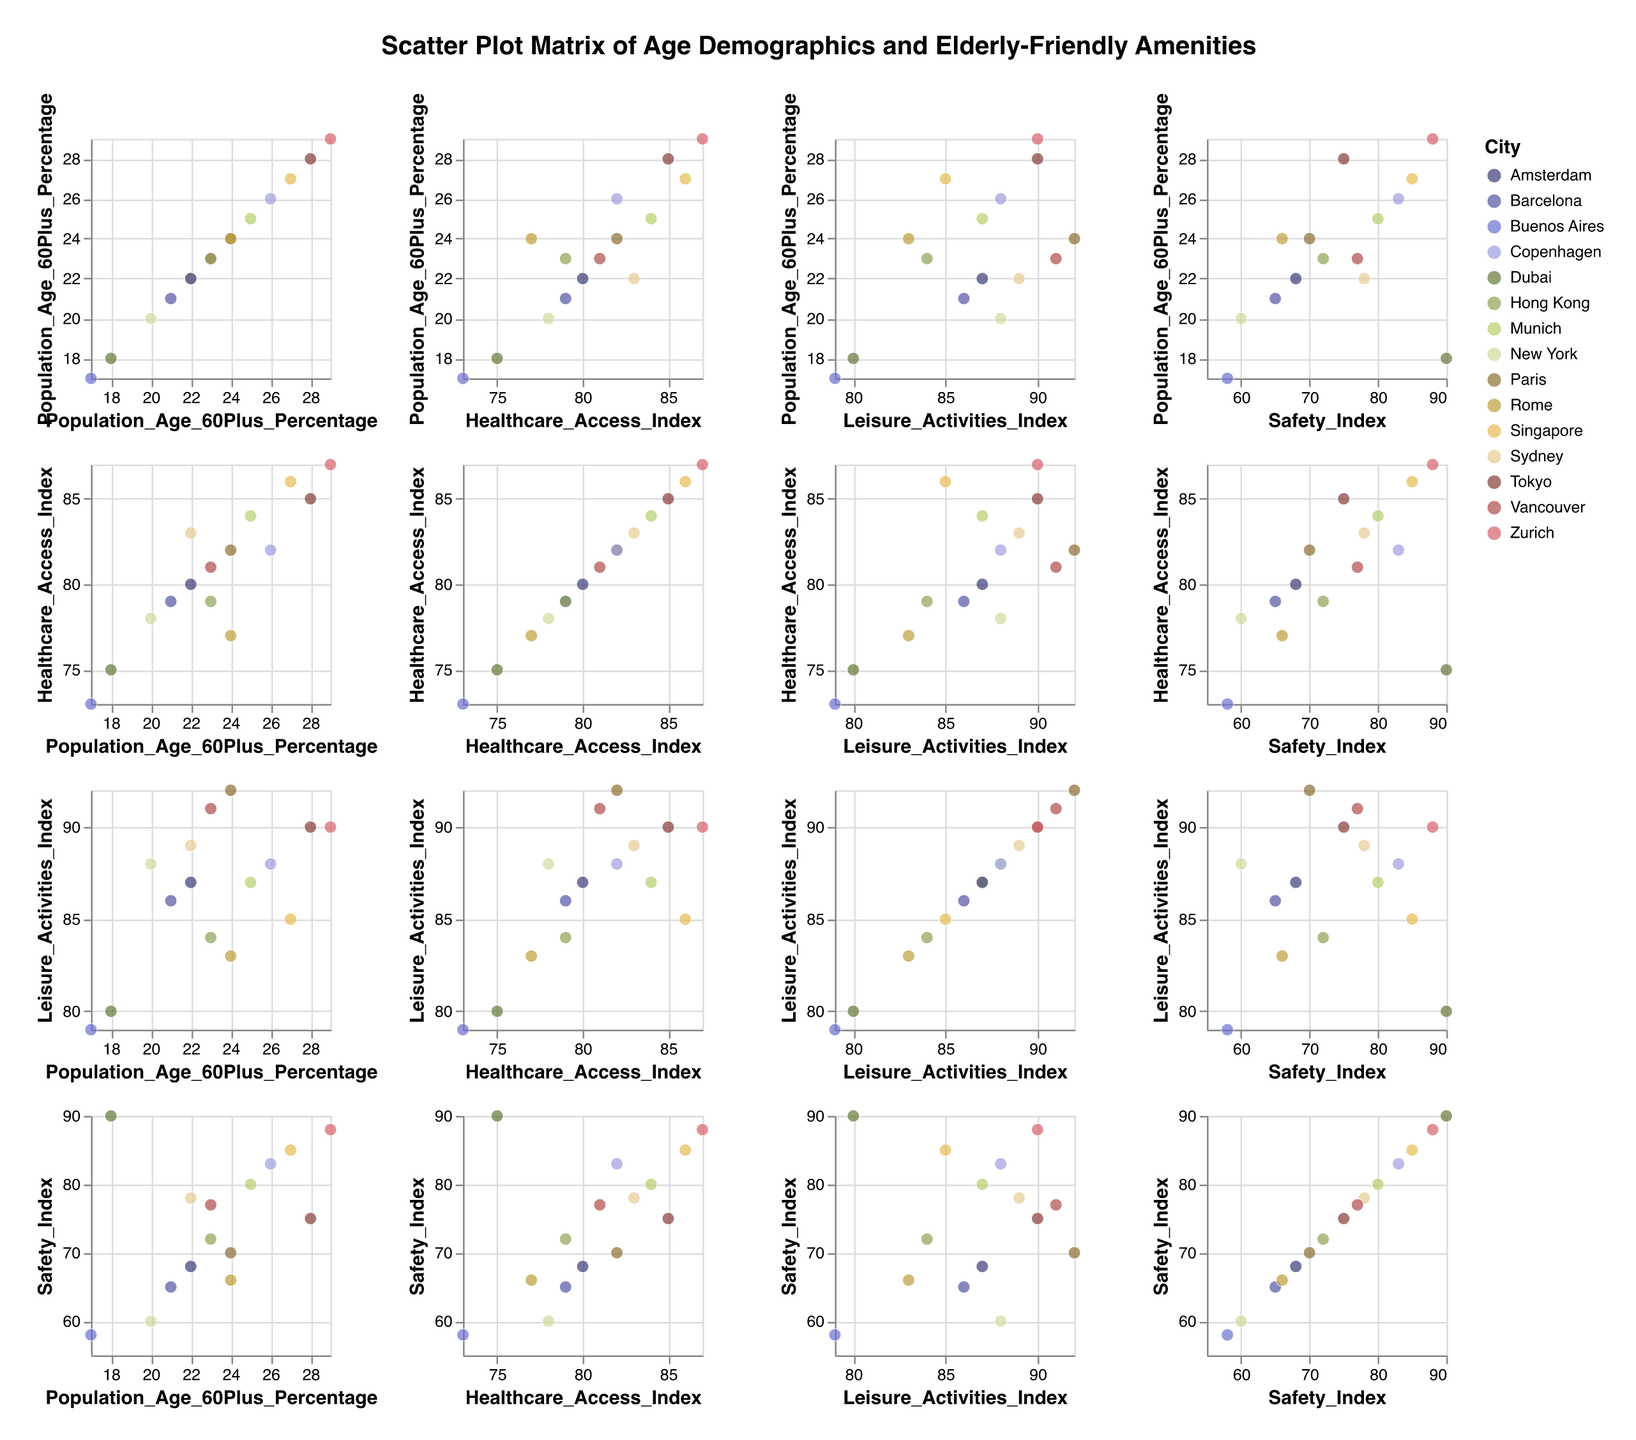What is the title of the figure? The title is displayed at the top of the figure and reads "Scatter Plot Matrix of Age Demographics and Elderly-Friendly Amenities."
Answer: Scatter Plot Matrix of Age Demographics and Elderly-Friendly Amenities Which city has the highest percentage of population aged 60 and above? By looking at the intersection column and row of "Population_Age_60Plus_Percentage," Zurich has the highest value at 29%.
Answer: Zurich Which cities have a Healthcare Access Index greater than or equal to 85? By examining the intersections of "Healthcare_Access_Index," cities with indices 85 or above are found. These cities are Tokyo, Singapore, and Zurich.
Answer: Tokyo, Singapore, Zurich Which city has the lowest Safety Index? By observing the row or column of "Safety_Index," Buenos Aires has the lowest value at 58.
Answer: Buenos Aires What is the average percentage of population aged 60 and above across all cities? Sum the percentages and divide by the number of cities: (28 + 24 + 20 + 25 + 22 + 23 + 21 + 27 + 26 + 22 + 29 + 23 + 24 + 18 + 17) / 15 = 339 / 15 = 22.6%.
Answer: 22.6% Do cities with a higher Safety Index also have better Healthcare Access? Compare pairs of "Safety_Index" and "Healthcare_Access_Index" values. Generally, cities with higher safety indices (like Zurich, Singapore) also have better healthcare access, but this is not a strict rule.
Answer: Generally yes, but not always What patterns do you notice between Leisure Activities Index and Healthcare Access Index across different cities? By analyzing the scatter plots at the intersections of "Leisure_Activities_Index" and "Healthcare_Access_Index," there is a slight positive correlation, indicating that cities with better healthcare also tend to have more leisure activities.
Answer: Positive correlation Which city ranks highest in both Leisure Activities Index and Safety Index? By looking at intersections of "Leisure_Activities_Index" and "Safety_Index," Zurich has the highest values in both indices (90 and 88, respectively).
Answer: Zurich Is there any city with a significant population aged 60 and above but lower values in Healthcare Access and Safety Index? Check for high "Population_Age_60Plus_Percentage" values intersecting with low "Healthcare_Access_Index" and "Safety_Index." No city fits this perfectly; the closest is Paris with 24% aged 60+, a healthcare index of 82, and a safety index of 70.
Answer: Paris Which index shows the most varied values among the cities? By comparing the ranges in scatter plots, "Safety_Index" shows more variation, ranging from 58 to 90.
Answer: Safety_Index 